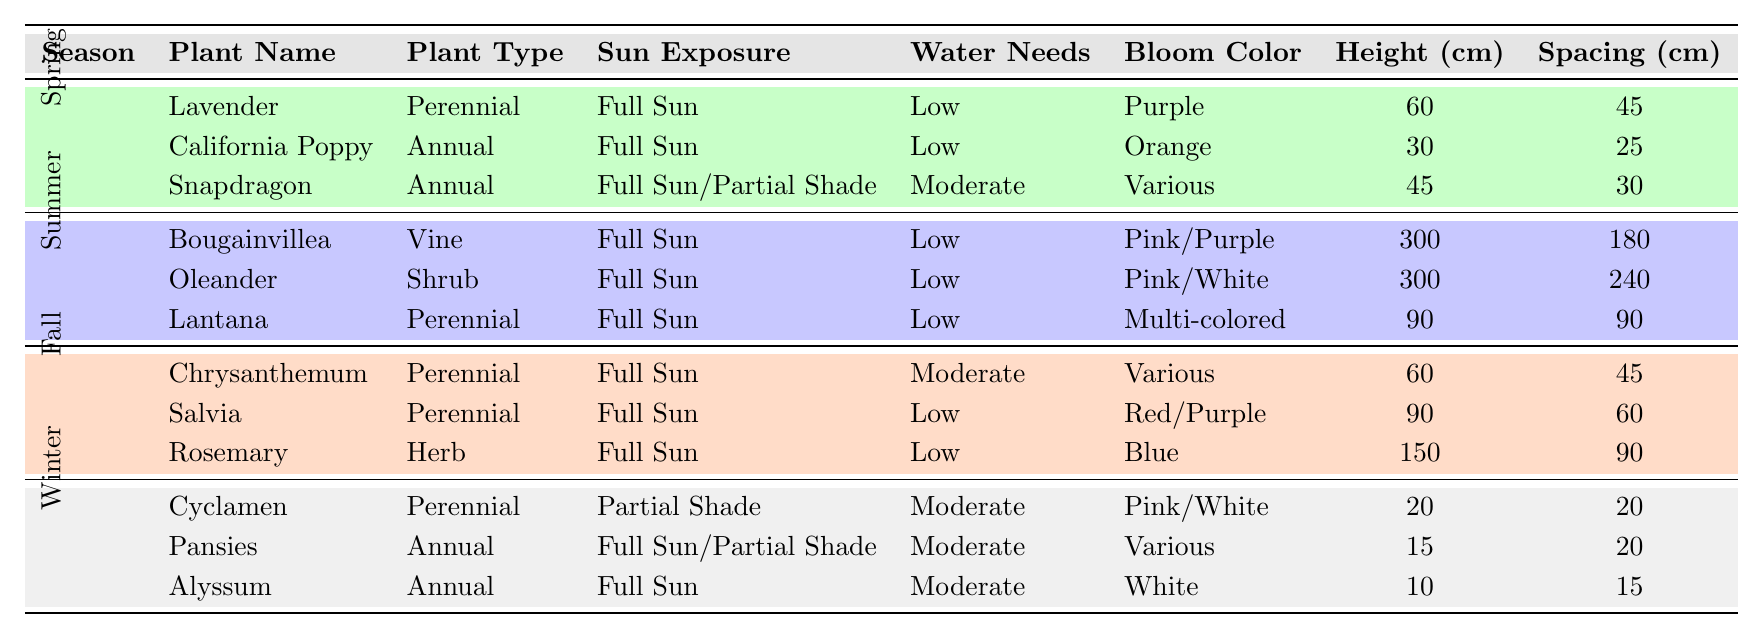What are the sun exposure requirements for Lavender? Lavender has a sun exposure requirement of "Full Sun" as indicated in the table.
Answer: Full Sun Which plant has the highest height in centimeters? Bougainvillea and Oleander both are listed with the height of 300 cm, making them the tallest plants in the table.
Answer: Bougainvillea and Oleander Do all plants listed for Spring have low water needs? Yes, all plants listed for Spring (Lavender, California Poppy, and Snapdragon) have "Low" water needs according to the table.
Answer: Yes Which season features the plant Lantana? Lantana is listed under the Summer season in the table.
Answer: Summer What is the average height of the plants in Fall? The heights of the Fall plants are 60 cm (Chrysanthemum), 90 cm (Salvia), and 150 cm (Rosemary). Their sum is 60 + 90 + 150 = 300 cm. The average is 300 / 3 = 100 cm.
Answer: 100 cm Is there any plant that requires partial shade among the Winter plants? Yes, Cyclamen is the only plant in the Winter section that requires "Partial Shade."
Answer: Yes How many annual plants are listed for Winter? The table shows two annual plants for Winter: Pansies and Alyssum.
Answer: 2 Which plant has the most varied bloom color? Lantana is noted for its "Multi-colored" bloom, indicating the greatest variety in bloom color of the plants listed.
Answer: Lantana What plant type is California Poppy? California Poppy is classified as an "Annual" plant in the table.
Answer: Annual Are there any low water needs plants in winter? Yes, both Pansies and Alyssum are annual plants in Winter that have "Moderate" water needs, which means they do not fall into the low category. Thus, there are no low water needs plants in Winter.
Answer: No 